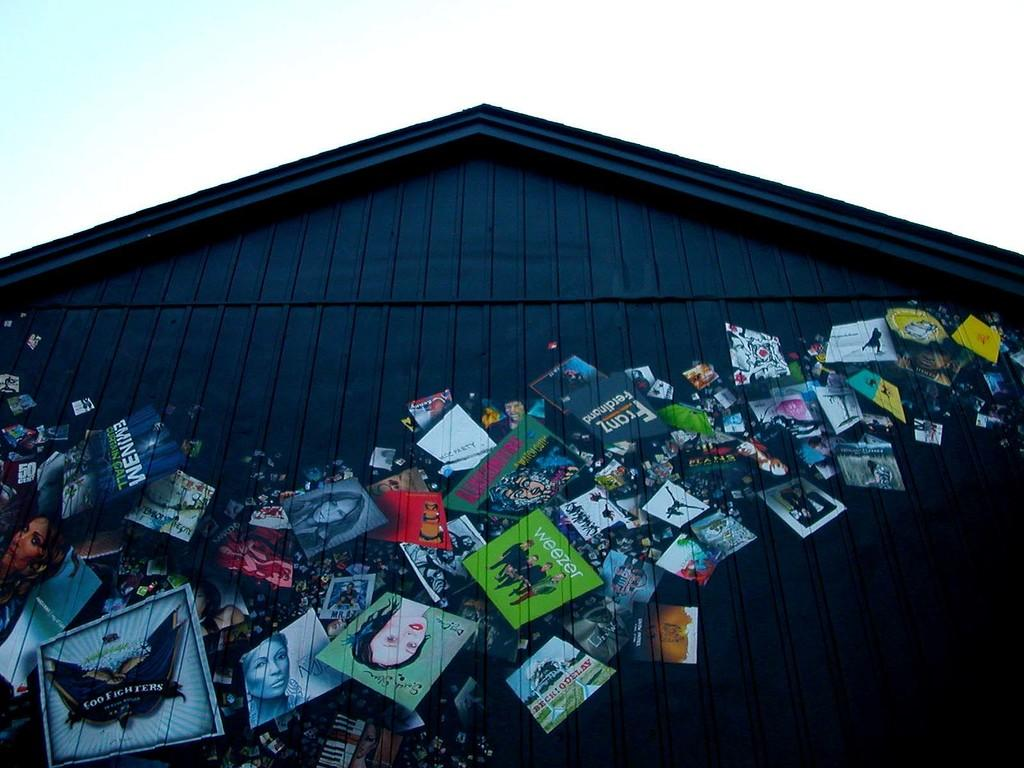What type of structure is present in the image? There is a house in the image. What architectural features can be seen on the house? There are posts on the house. What is the condition of the sky in the image? The sky is blue and cloudy in the image. Can you tell me how many waves are crashing against the house in the image? There are no waves present in the image, as it features a house with posts and a blue, cloudy sky. What type of change can be seen happening to the scene in the image? There is no indication of any change happening to the scene in the image. 